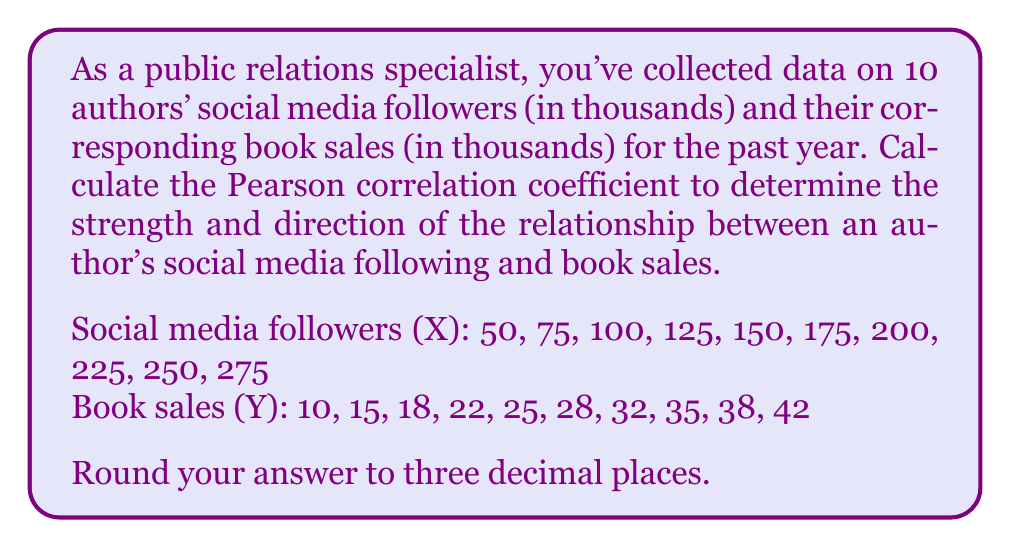Could you help me with this problem? To calculate the Pearson correlation coefficient (r), we'll use the formula:

$$ r = \frac{n\sum xy - \sum x \sum y}{\sqrt{[n\sum x^2 - (\sum x)^2][n\sum y^2 - (\sum y)^2]}} $$

Step 1: Calculate the sums and squared sums:
$\sum x = 1625$, $\sum y = 265$, $\sum xy = 46,725$
$\sum x^2 = 331,875$, $\sum y^2 = 7,713$

Step 2: Calculate $n\sum xy$ and $\sum x \sum y$:
$n\sum xy = 10 \times 46,725 = 467,250$
$\sum x \sum y = 1625 \times 265 = 430,625$

Step 3: Calculate the numerator:
$n\sum xy - \sum x \sum y = 467,250 - 430,625 = 36,625$

Step 4: Calculate the denominator:
$n\sum x^2 - (\sum x)^2 = 10 \times 331,875 - 1625^2 = 3,318,750 - 2,640,625 = 678,125$
$n\sum y^2 - (\sum y)^2 = 10 \times 7,713 - 265^2 = 77,130 - 70,225 = 6,905$

$\sqrt{[n\sum x^2 - (\sum x)^2][n\sum y^2 - (\sum y)^2]} = \sqrt{678,125 \times 6,905} = 68,371.97$

Step 5: Calculate the correlation coefficient:
$r = \frac{36,625}{68,371.97} = 0.5357$

Step 6: Round to three decimal places:
$r = 0.536$
Answer: 0.536 